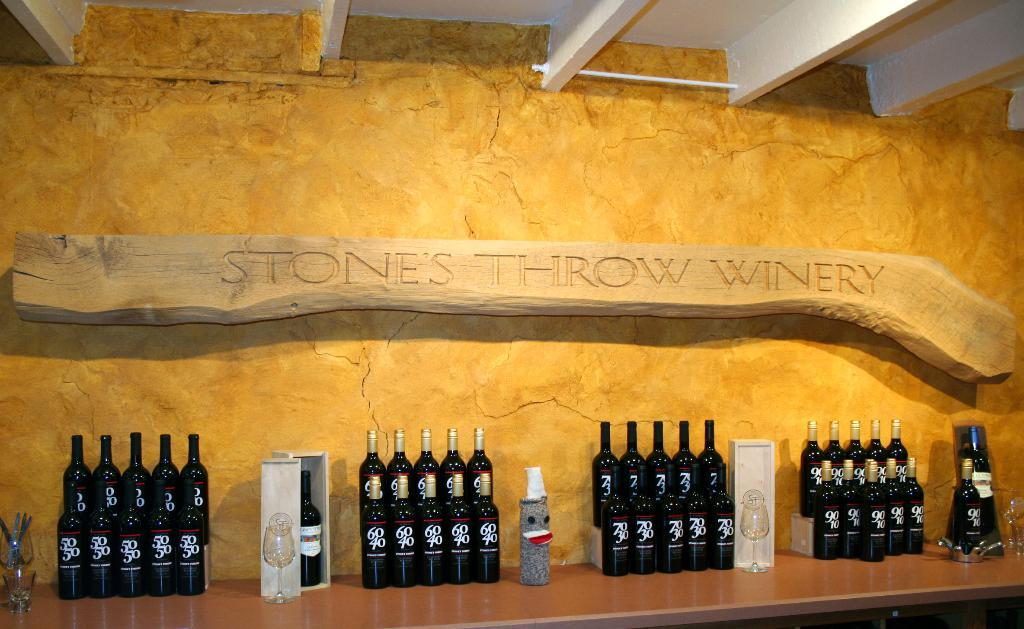<image>
Offer a succinct explanation of the picture presented. Stone throw winery is displaying their wines on a wooden counter behind a yellow background 